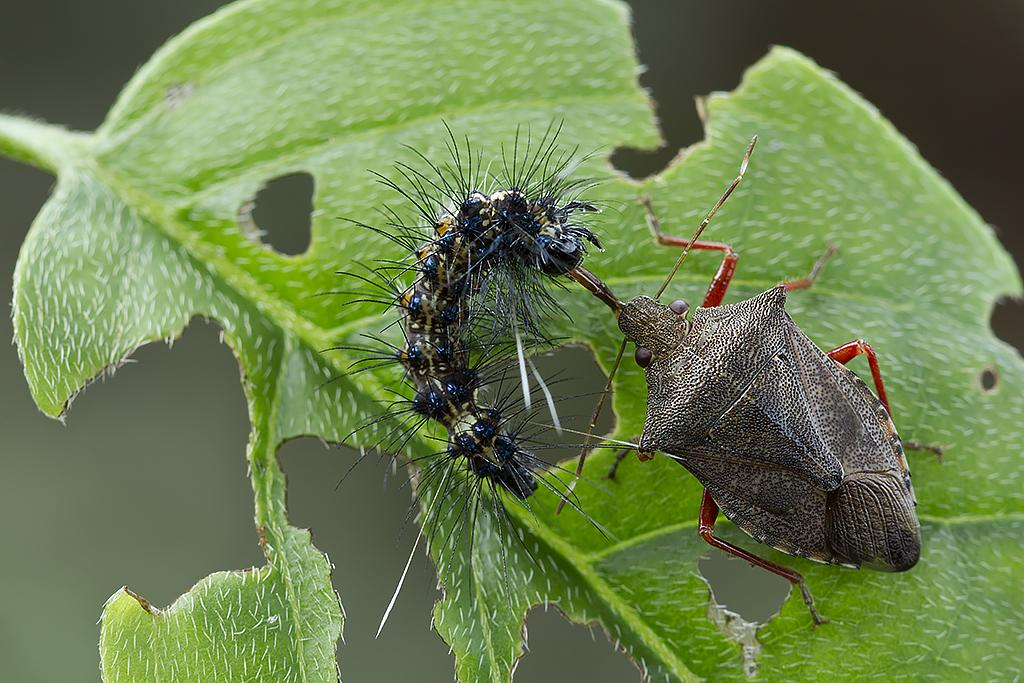What is the main subject of the image? The main subject of the image is insects on a leaf. Can you describe the background of the image? The background of the image is blurred. Where is the rabbit hiding under the umbrella in the image? There is no rabbit or umbrella present in the image; it features insects on a leaf with a blurred background. 